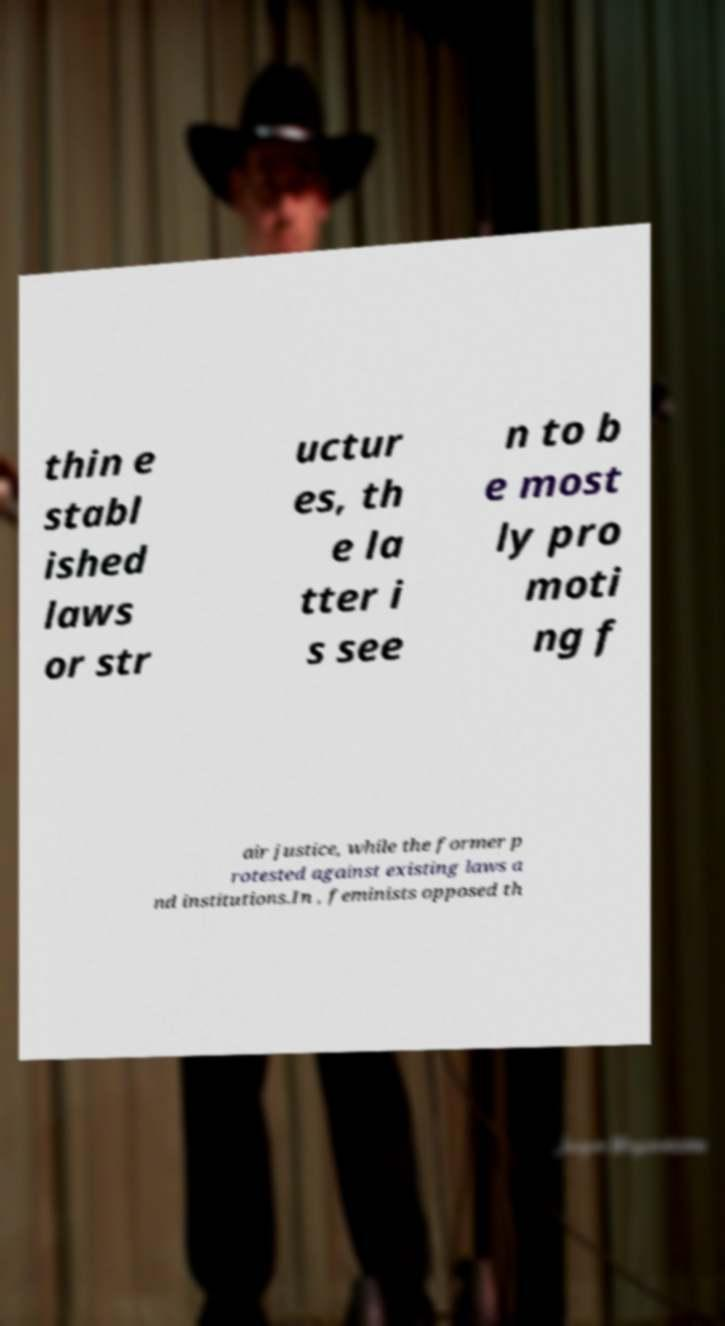Can you read and provide the text displayed in the image?This photo seems to have some interesting text. Can you extract and type it out for me? thin e stabl ished laws or str uctur es, th e la tter i s see n to b e most ly pro moti ng f air justice, while the former p rotested against existing laws a nd institutions.In , feminists opposed th 